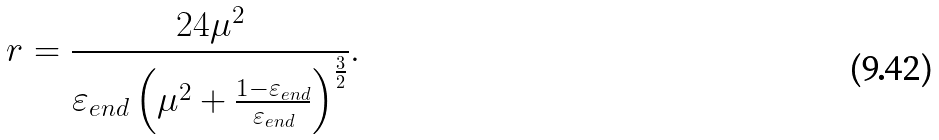Convert formula to latex. <formula><loc_0><loc_0><loc_500><loc_500>r = \frac { 2 4 \mu ^ { 2 } } { \varepsilon _ { e n d } \left ( \mu ^ { 2 } + \frac { 1 - \varepsilon _ { e n d } } { \varepsilon _ { e n d } } \right ) ^ { \frac { 3 } { 2 } } } .</formula> 